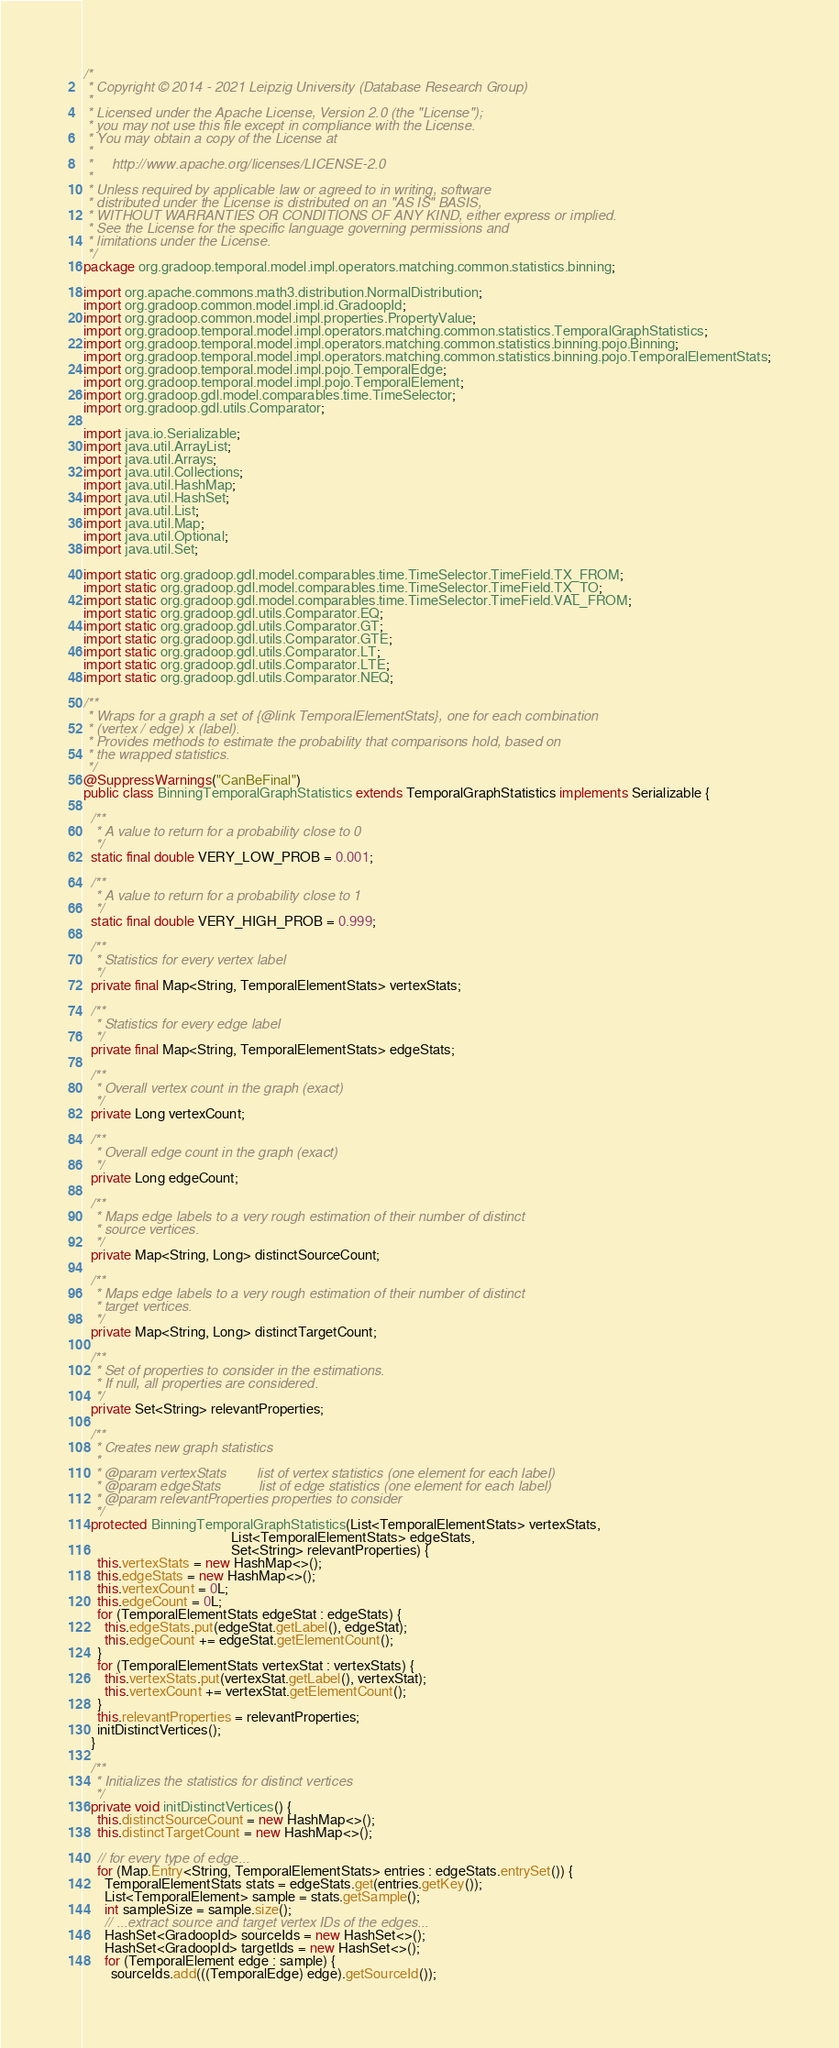<code> <loc_0><loc_0><loc_500><loc_500><_Java_>/*
 * Copyright © 2014 - 2021 Leipzig University (Database Research Group)
 *
 * Licensed under the Apache License, Version 2.0 (the "License");
 * you may not use this file except in compliance with the License.
 * You may obtain a copy of the License at
 *
 *     http://www.apache.org/licenses/LICENSE-2.0
 *
 * Unless required by applicable law or agreed to in writing, software
 * distributed under the License is distributed on an "AS IS" BASIS,
 * WITHOUT WARRANTIES OR CONDITIONS OF ANY KIND, either express or implied.
 * See the License for the specific language governing permissions and
 * limitations under the License.
 */
package org.gradoop.temporal.model.impl.operators.matching.common.statistics.binning;

import org.apache.commons.math3.distribution.NormalDistribution;
import org.gradoop.common.model.impl.id.GradoopId;
import org.gradoop.common.model.impl.properties.PropertyValue;
import org.gradoop.temporal.model.impl.operators.matching.common.statistics.TemporalGraphStatistics;
import org.gradoop.temporal.model.impl.operators.matching.common.statistics.binning.pojo.Binning;
import org.gradoop.temporal.model.impl.operators.matching.common.statistics.binning.pojo.TemporalElementStats;
import org.gradoop.temporal.model.impl.pojo.TemporalEdge;
import org.gradoop.temporal.model.impl.pojo.TemporalElement;
import org.gradoop.gdl.model.comparables.time.TimeSelector;
import org.gradoop.gdl.utils.Comparator;

import java.io.Serializable;
import java.util.ArrayList;
import java.util.Arrays;
import java.util.Collections;
import java.util.HashMap;
import java.util.HashSet;
import java.util.List;
import java.util.Map;
import java.util.Optional;
import java.util.Set;

import static org.gradoop.gdl.model.comparables.time.TimeSelector.TimeField.TX_FROM;
import static org.gradoop.gdl.model.comparables.time.TimeSelector.TimeField.TX_TO;
import static org.gradoop.gdl.model.comparables.time.TimeSelector.TimeField.VAL_FROM;
import static org.gradoop.gdl.utils.Comparator.EQ;
import static org.gradoop.gdl.utils.Comparator.GT;
import static org.gradoop.gdl.utils.Comparator.GTE;
import static org.gradoop.gdl.utils.Comparator.LT;
import static org.gradoop.gdl.utils.Comparator.LTE;
import static org.gradoop.gdl.utils.Comparator.NEQ;

/**
 * Wraps for a graph a set of {@link TemporalElementStats}, one for each combination
 * (vertex / edge) x (label).
 * Provides methods to estimate the probability that comparisons hold, based on
 * the wrapped statistics.
 */
@SuppressWarnings("CanBeFinal")
public class BinningTemporalGraphStatistics extends TemporalGraphStatistics implements Serializable {

  /**
   * A value to return for a probability close to 0
   */
  static final double VERY_LOW_PROB = 0.001;

  /**
   * A value to return for a probability close to 1
   */
  static final double VERY_HIGH_PROB = 0.999;

  /**
   * Statistics for every vertex label
   */
  private final Map<String, TemporalElementStats> vertexStats;

  /**
   * Statistics for every edge label
   */
  private final Map<String, TemporalElementStats> edgeStats;

  /**
   * Overall vertex count in the graph (exact)
   */
  private Long vertexCount;

  /**
   * Overall edge count in the graph (exact)
   */
  private Long edgeCount;

  /**
   * Maps edge labels to a very rough estimation of their number of distinct
   * source vertices.
   */
  private Map<String, Long> distinctSourceCount;

  /**
   * Maps edge labels to a very rough estimation of their number of distinct
   * target vertices.
   */
  private Map<String, Long> distinctTargetCount;

  /**
   * Set of properties to consider in the estimations.
   * If null, all properties are considered.
   */
  private Set<String> relevantProperties;

  /**
   * Creates new graph statistics
   *
   * @param vertexStats        list of vertex statistics (one element for each label)
   * @param edgeStats          list of edge statistics (one element for each label)
   * @param relevantProperties properties to consider
   */
  protected BinningTemporalGraphStatistics(List<TemporalElementStats> vertexStats,
                                           List<TemporalElementStats> edgeStats,
                                           Set<String> relevantProperties) {
    this.vertexStats = new HashMap<>();
    this.edgeStats = new HashMap<>();
    this.vertexCount = 0L;
    this.edgeCount = 0L;
    for (TemporalElementStats edgeStat : edgeStats) {
      this.edgeStats.put(edgeStat.getLabel(), edgeStat);
      this.edgeCount += edgeStat.getElementCount();
    }
    for (TemporalElementStats vertexStat : vertexStats) {
      this.vertexStats.put(vertexStat.getLabel(), vertexStat);
      this.vertexCount += vertexStat.getElementCount();
    }
    this.relevantProperties = relevantProperties;
    initDistinctVertices();
  }

  /**
   * Initializes the statistics for distinct vertices
   */
  private void initDistinctVertices() {
    this.distinctSourceCount = new HashMap<>();
    this.distinctTargetCount = new HashMap<>();

    // for every type of edge...
    for (Map.Entry<String, TemporalElementStats> entries : edgeStats.entrySet()) {
      TemporalElementStats stats = edgeStats.get(entries.getKey());
      List<TemporalElement> sample = stats.getSample();
      int sampleSize = sample.size();
      // ...extract source and target vertex IDs of the edges...
      HashSet<GradoopId> sourceIds = new HashSet<>();
      HashSet<GradoopId> targetIds = new HashSet<>();
      for (TemporalElement edge : sample) {
        sourceIds.add(((TemporalEdge) edge).getSourceId());</code> 